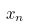Convert formula to latex. <formula><loc_0><loc_0><loc_500><loc_500>x _ { n }</formula> 